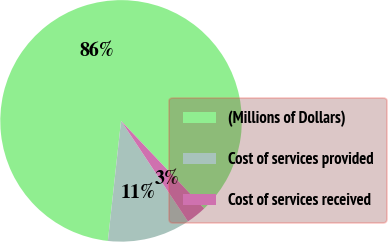<chart> <loc_0><loc_0><loc_500><loc_500><pie_chart><fcel>(Millions of Dollars)<fcel>Cost of services provided<fcel>Cost of services received<nl><fcel>86.18%<fcel>11.08%<fcel>2.74%<nl></chart> 